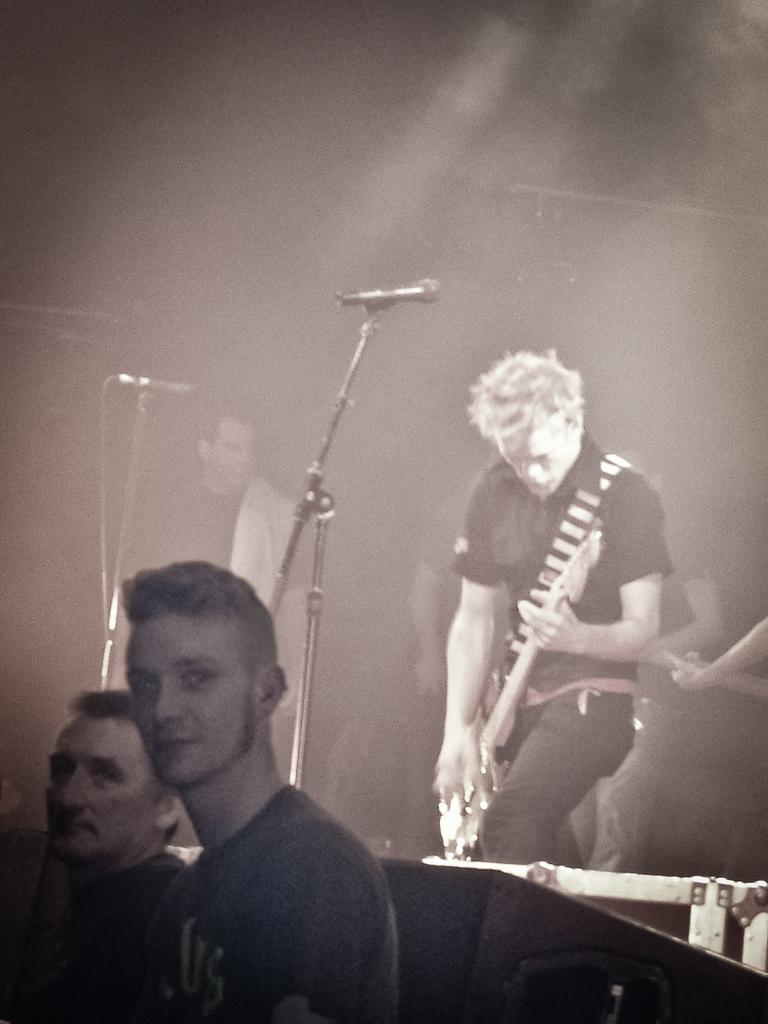What is the main activity being performed by the person in the image? The person in the image is playing a guitar. How many other people are present in the image? There are two other persons standing in the image. What object is associated with the activity of singing or speaking in the image? There is a microphone in the image. Can you tell me where the pump is located in the image? There is no pump present in the image. What type of card is being used by the person playing the guitar? There is no card being used by the person playing the guitar in the image. 